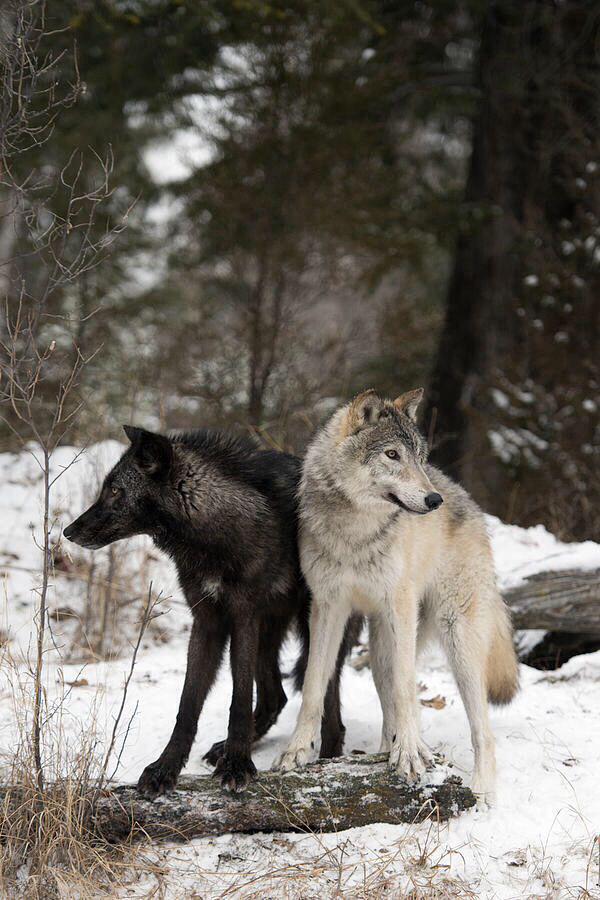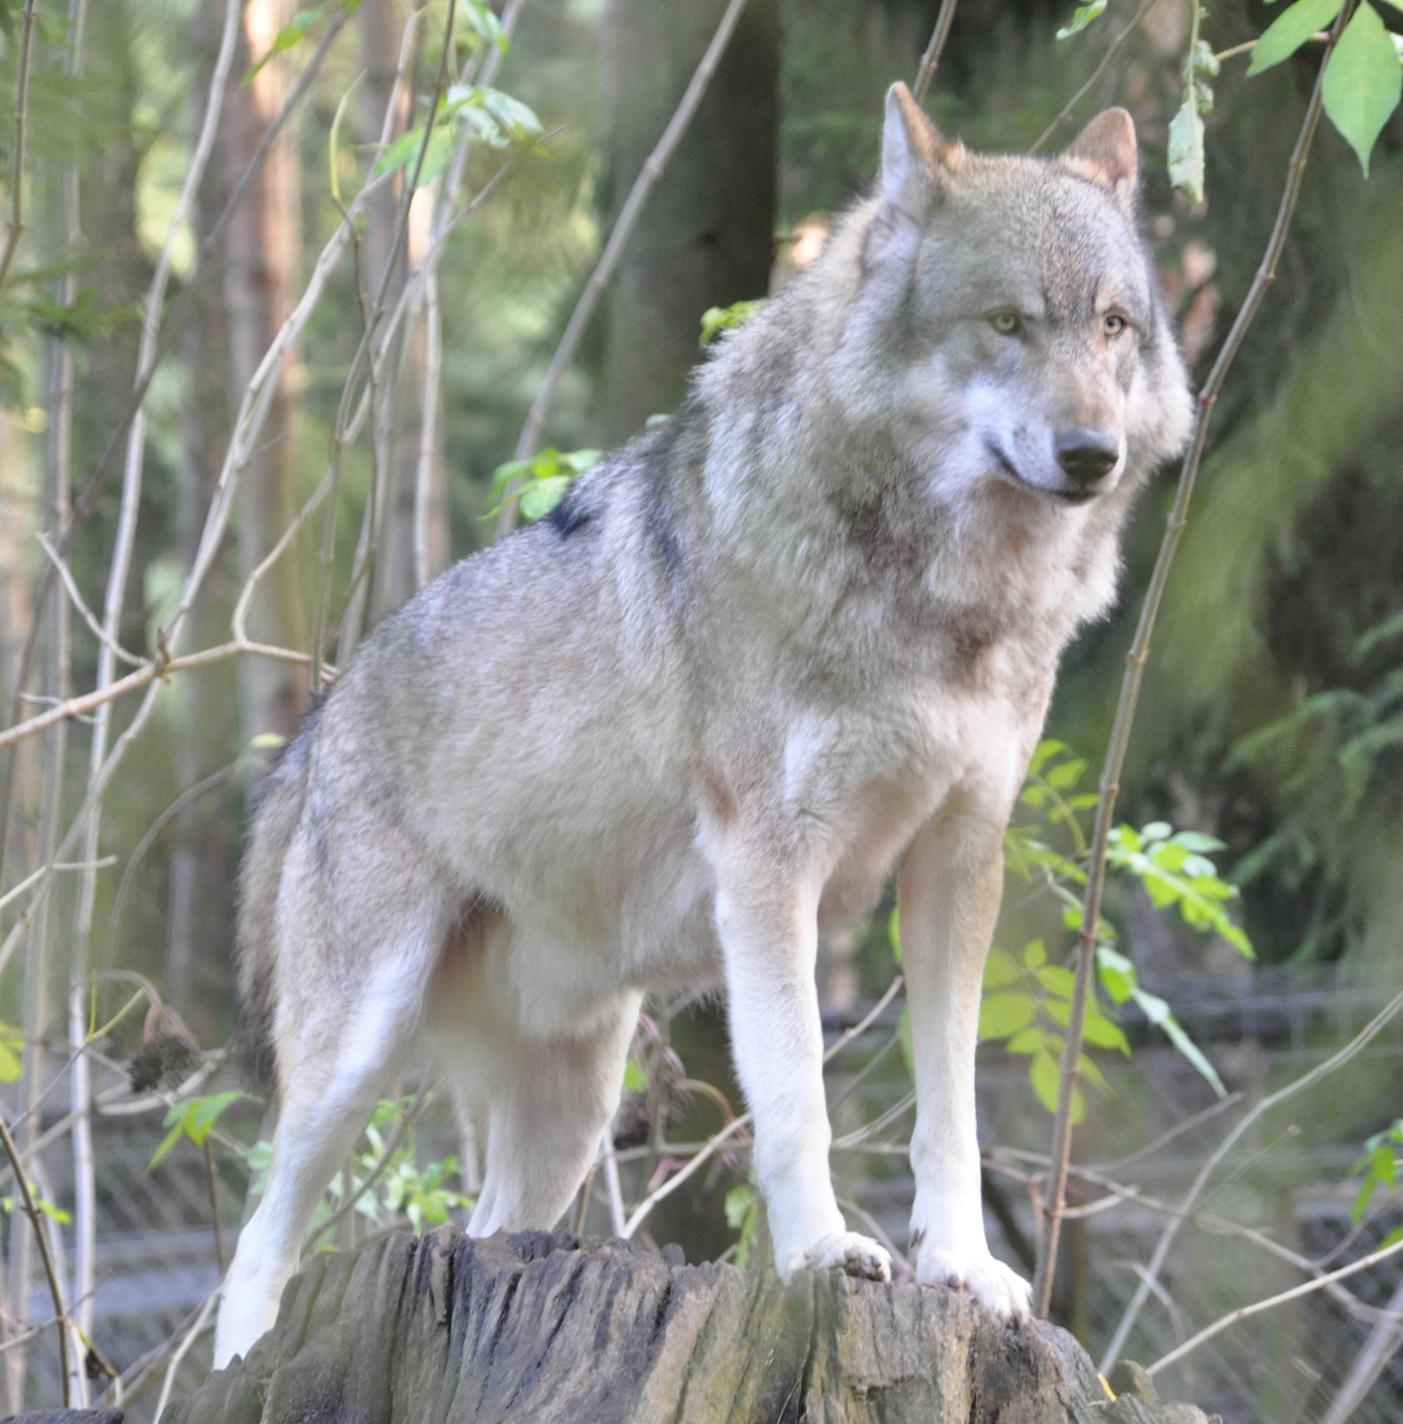The first image is the image on the left, the second image is the image on the right. Evaluate the accuracy of this statement regarding the images: "Two wolves are hanging out together in one of the pictures.". Is it true? Answer yes or no. Yes. The first image is the image on the left, the second image is the image on the right. For the images displayed, is the sentence "One image contains twice as many wolves as the other image." factually correct? Answer yes or no. Yes. 